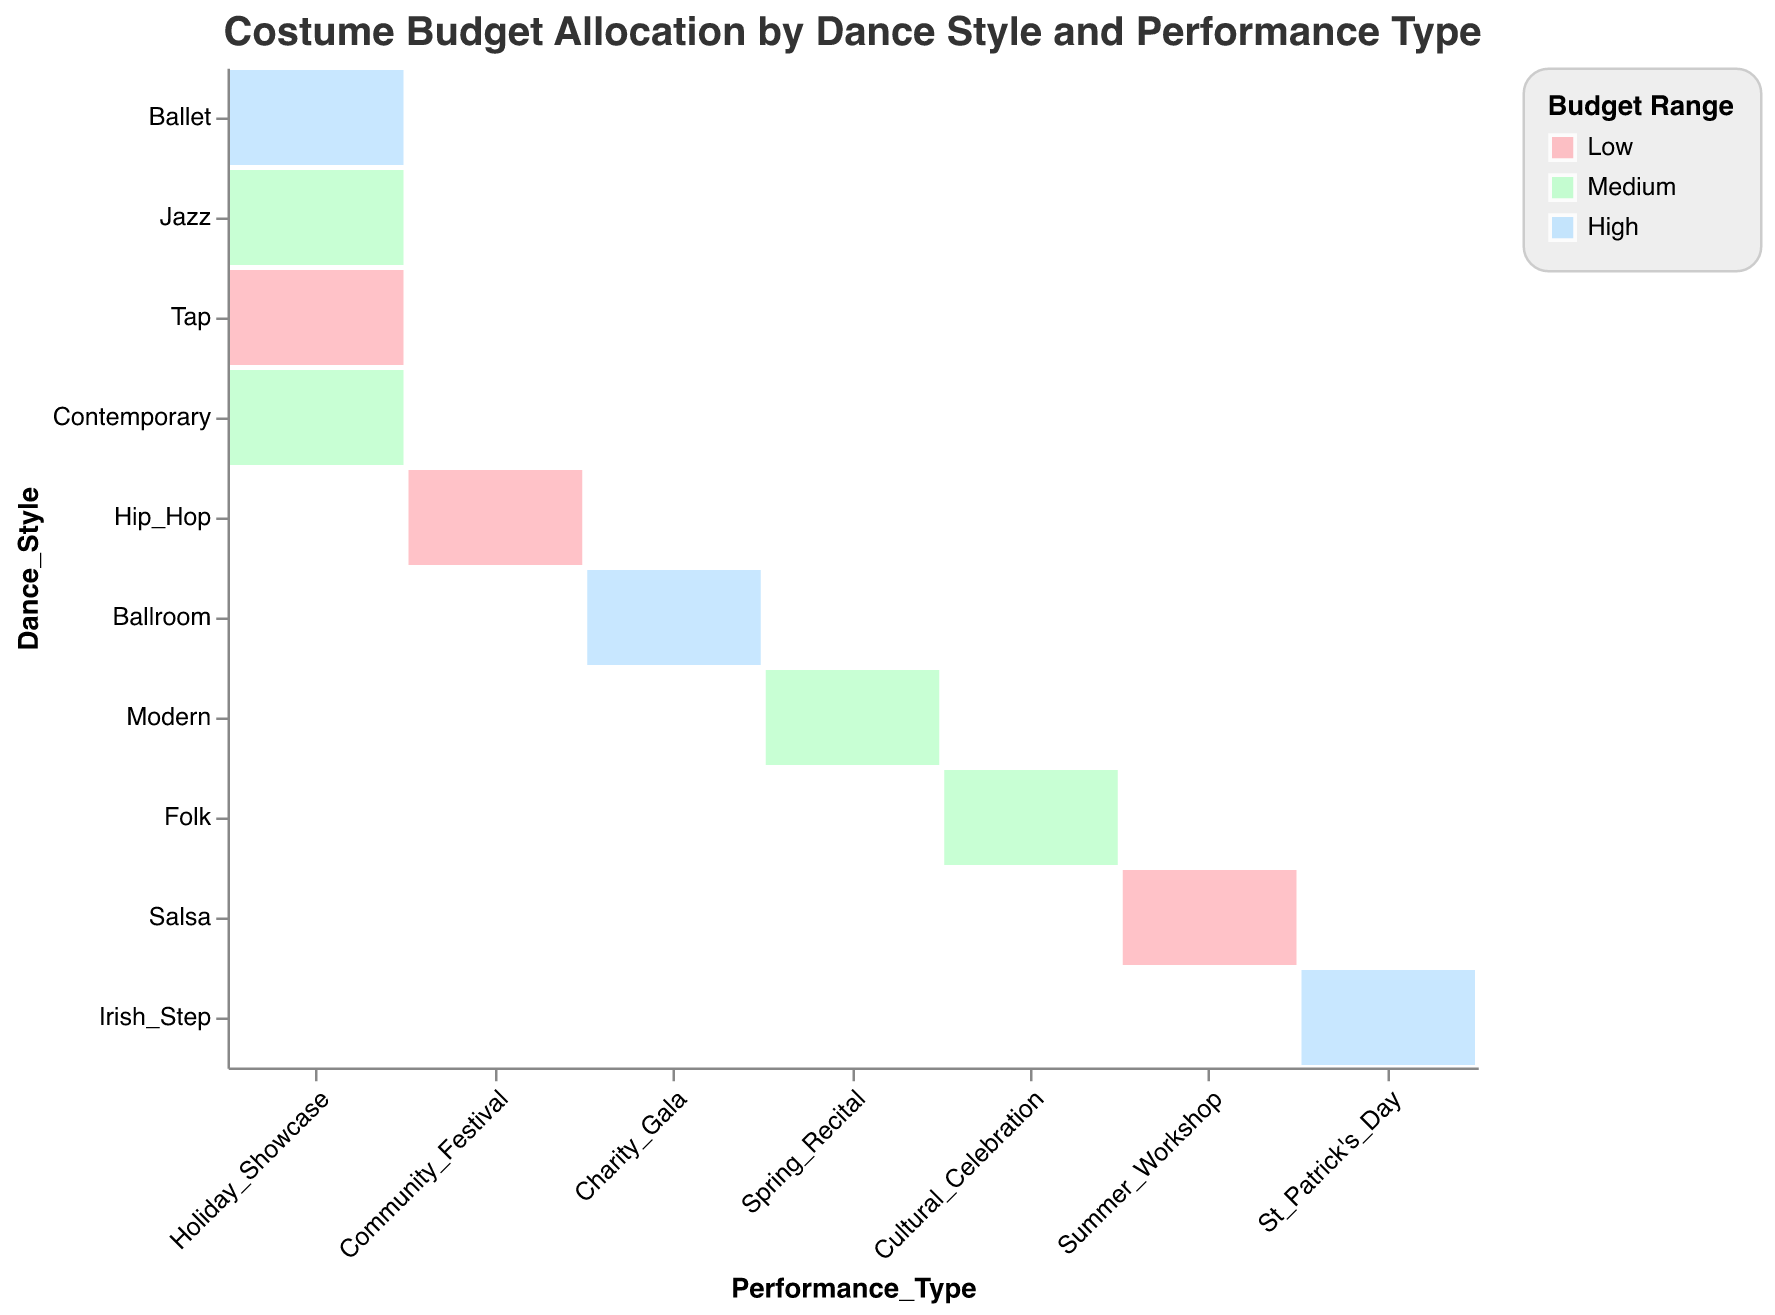How many types of performance types are there? The x-axis lists all the different performance types; by counting them, we identify six distinct types.
Answer: Six What budget range is the most common among the dance styles in Holiday Showcase? Looking at all the dance styles under "Holiday Showcase," we see one "High," two "Medium," and one "Low" budget range.
Answer: Medium Which performance type has the highest number of dance styles with a high budget range? By observing each performance type, we note that “Holiday Showcase,” “Charity Gala,” and “St Patrick’s Day” each have one dance style with a high budget range.
Answer: Three-way tie Is there any dance style with a low budget range in the performance type Work_shop? Reviewing the various dance styles under “Summer Workshop,” we confirm there is one dance style, “Salsa,” with a low budget range.
Answer: Yes Comparing "Holiday Showcase" and "Spring Recital," which has more dance styles with medium budget ranges? By counting, “Holiday Showcase” has two ("Jazz" and "Contemporary") while "Spring Recital" has one ("Modern").
Answer: Holiday Showcase Which dance style has a medium budget range in the Charity Gala performance type? By identifying the budget ranges in the "Charity Gala," we see "Ballroom" is listed but has a high budget range, so none have a medium budget.
Answer: None What is the most common budget range across all performance types? By counting the occurrences of each budget range across all performance types, we see "Medium" appears four times, "High" three times, and "Low" three times.
Answer: Medium How many dance styles are associated with each budget range? Counting all dance styles per budget range reveals: High (3), Medium (4), Low (3).
Answer: High: 3, Medium: 4, Low: 3 What budget range is used for Ballet in the Holiday Showcase? Observing the budget range for Ballet listed under “Holiday Showcase” reveals it is a high budget range.
Answer: High Which performance type is the only one with the "Irish Step" dance style, and what is its budget range? "Irish Step" appears under “St. Patrick's Day” with a high budget range.
Answer: St. Patrick's Day, High 